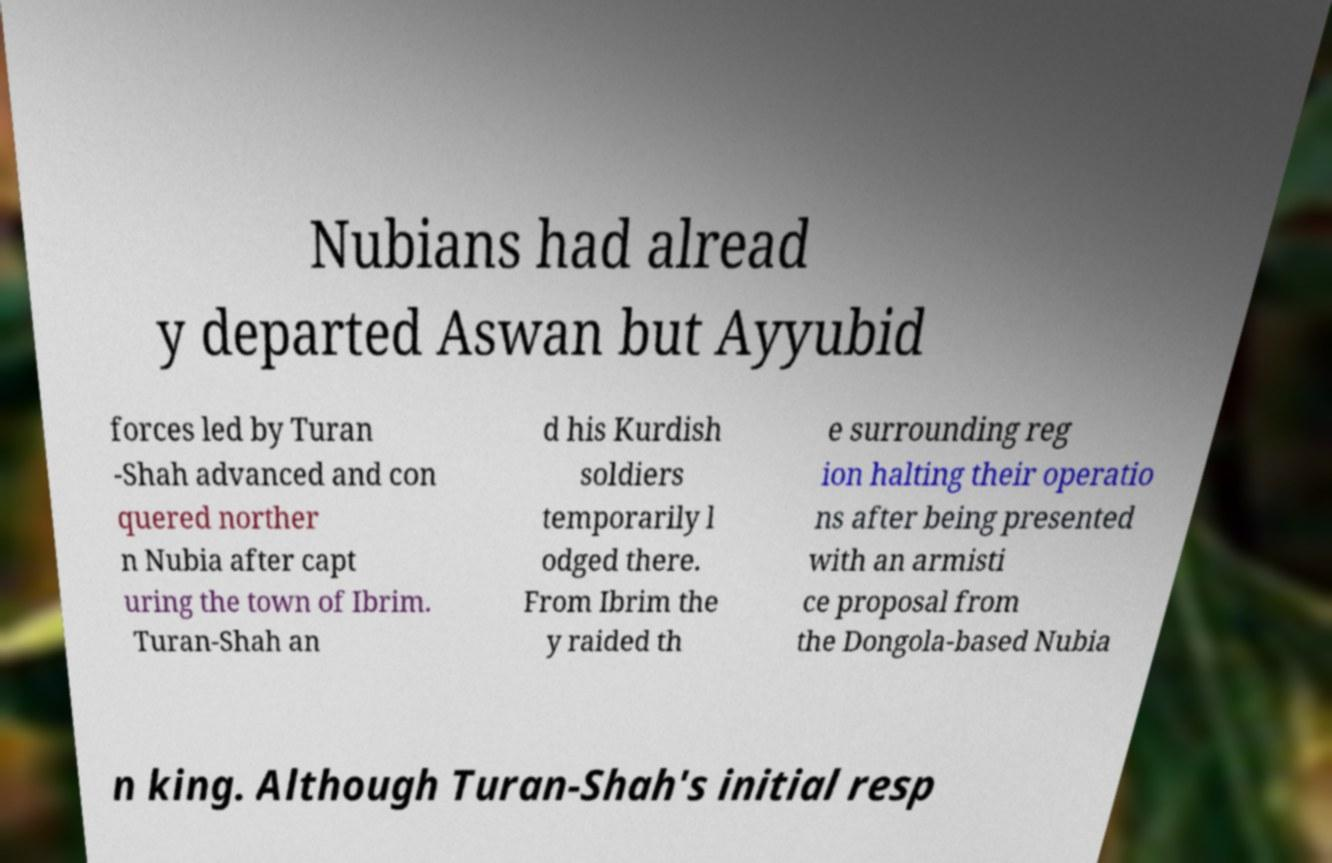Can you accurately transcribe the text from the provided image for me? Nubians had alread y departed Aswan but Ayyubid forces led by Turan -Shah advanced and con quered norther n Nubia after capt uring the town of Ibrim. Turan-Shah an d his Kurdish soldiers temporarily l odged there. From Ibrim the y raided th e surrounding reg ion halting their operatio ns after being presented with an armisti ce proposal from the Dongola-based Nubia n king. Although Turan-Shah's initial resp 